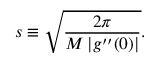Convert formula to latex. <formula><loc_0><loc_0><loc_500><loc_500>s \equiv \sqrt { \frac { 2 \pi } { M \left | g ^ { \prime \prime } ( 0 ) \right | } } .</formula> 